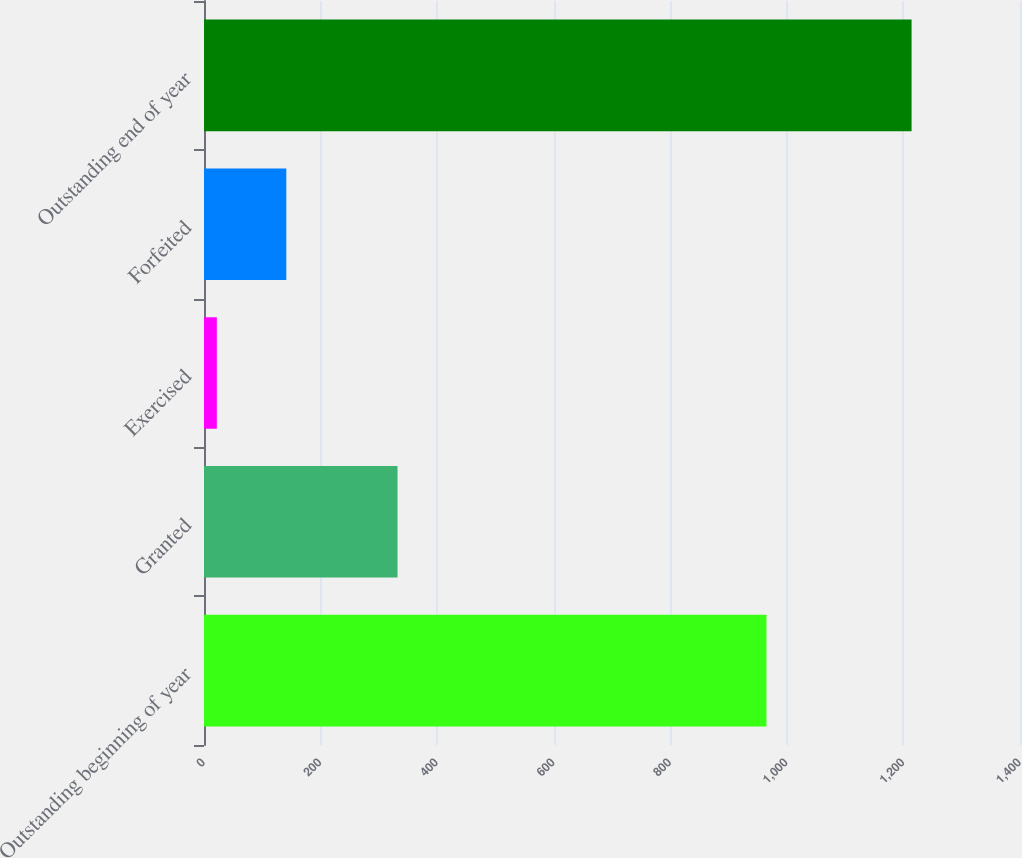Convert chart. <chart><loc_0><loc_0><loc_500><loc_500><bar_chart><fcel>Outstanding beginning of year<fcel>Granted<fcel>Exercised<fcel>Forfeited<fcel>Outstanding end of year<nl><fcel>965<fcel>332<fcel>22<fcel>141.2<fcel>1214<nl></chart> 